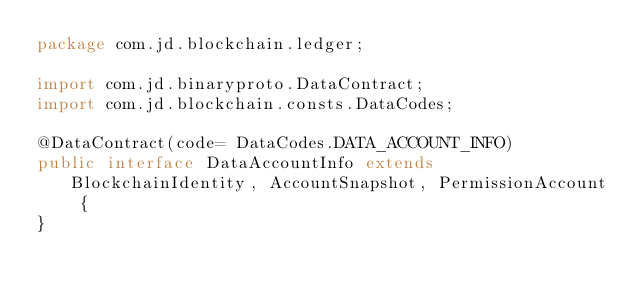<code> <loc_0><loc_0><loc_500><loc_500><_Java_>package com.jd.blockchain.ledger;

import com.jd.binaryproto.DataContract;
import com.jd.blockchain.consts.DataCodes;

@DataContract(code= DataCodes.DATA_ACCOUNT_INFO)
public interface DataAccountInfo extends BlockchainIdentity, AccountSnapshot, PermissionAccount {
}
</code> 